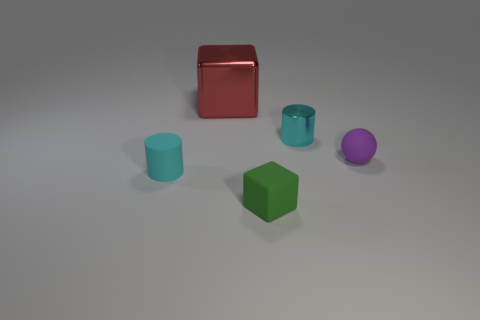Subtract all balls. How many objects are left? 4 Add 4 big red metallic things. How many objects exist? 9 Subtract all green cubes. How many cubes are left? 1 Subtract 0 yellow cylinders. How many objects are left? 5 Subtract all yellow spheres. Subtract all gray cylinders. How many spheres are left? 1 Subtract all purple spheres. How many gray cylinders are left? 0 Subtract all small cyan rubber cylinders. Subtract all small green rubber objects. How many objects are left? 3 Add 1 red shiny cubes. How many red shiny cubes are left? 2 Add 2 green cubes. How many green cubes exist? 3 